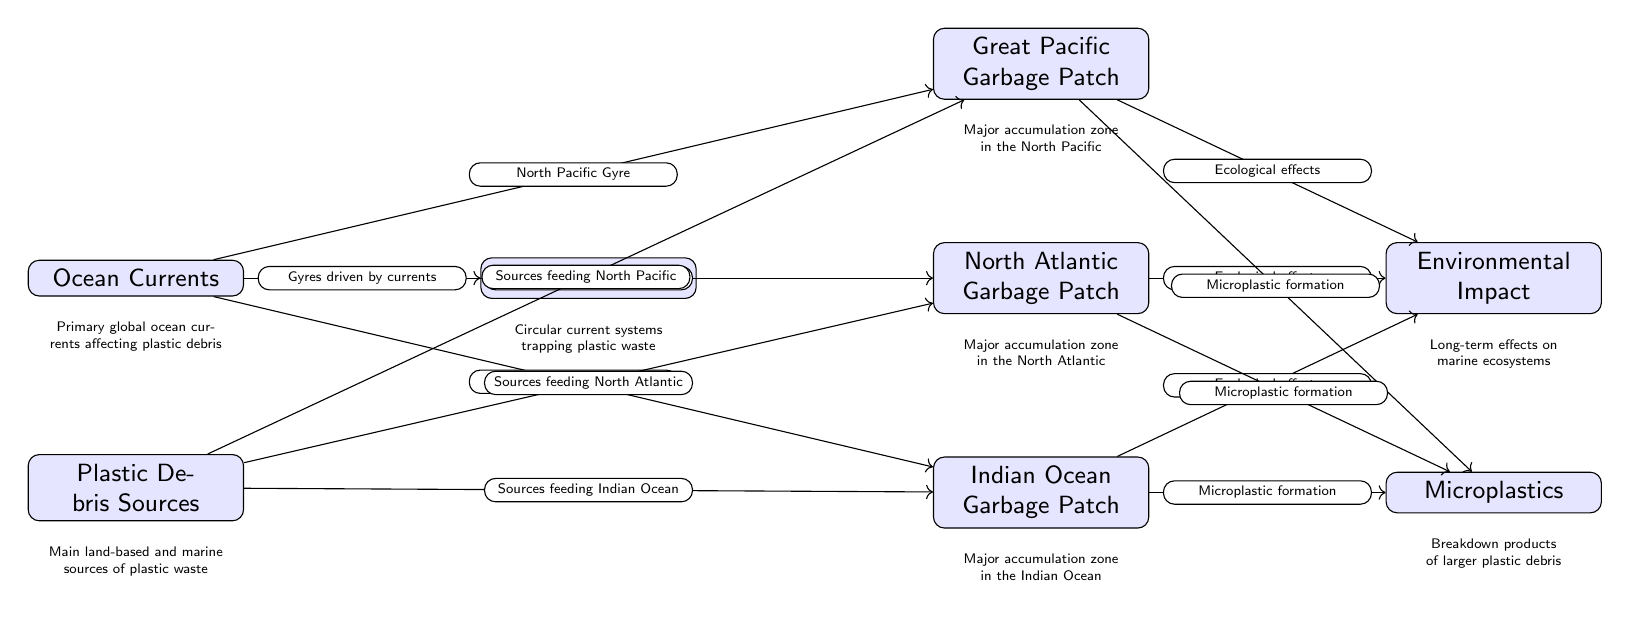What are the three major ocean gyres mentioned in the diagram? The diagram lists the three major ocean gyres feeding the garbage patches as: North Pacific Gyre, North Atlantic Gyre, and Indian Ocean Gyre.
Answer: North Pacific Gyre, North Atlantic Gyre, Indian Ocean Gyre What type of debris is formed from the ecological effects of the garbage patches? The diagram connects the garbage patches to the long-term effects on marine ecosystems, which specifically indicates that they lead to microplastic formation.
Answer: Microplastics How many plastic debris sources are indicated in the diagram? The diagram specifies one node for plastic debris sources, which gives us the total count of such sources feeding into each gyre, but does not enumerate them. Thus, there is one node indicating sources.
Answer: 1 Which gyre is associated with the Great Pacific Garbage Patch? The diagram directly shows an arrow from the North Pacific Gyre to the Great Pacific Garbage Patch, indicating their relationship.
Answer: North Pacific Gyre What is the main outcome of the ecological effects linked to the three plastic accumulation zones? The diagram clearly outlines that all three garbage patches have arrows leading to a single outcome node labeled "Environmental Impact," indicating their collective ecological effects.
Answer: Environmental Impact What is the distribution pattern of plastic debris summarized through? The diagram illustrates that the plastic debris sources feed into specific gyres, with arrows indicating this directional flow and interaction between nodes, specifically suggesting how ocean currents shape this distribution.
Answer: Ocean Currents What is the relationship between "Sources feeding North Atlantic" and "North Atlantic Garbage Patch"? The diagram shows a directed edge from the node "Plastic Debris Sources" to "North Atlantic Garbage Patch," indicating that those sources directly contribute to the accumulation of plastic debris in that specific gyre.
Answer: Sources feeding North Atlantic How is the concept of circular currents represented in the diagram? The diagram includes a node "Circular Gyres," which is positioned next to various garbage patches and is linked to "Ocean Currents," highlighting that gyres are driven by those currents trapping plastic waste.
Answer: Gyres driven by currents 